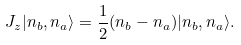Convert formula to latex. <formula><loc_0><loc_0><loc_500><loc_500>J _ { z } | n _ { b } , n _ { a } \rangle = \frac { 1 } { 2 } ( n _ { b } - n _ { a } ) | n _ { b } , n _ { a } \rangle .</formula> 